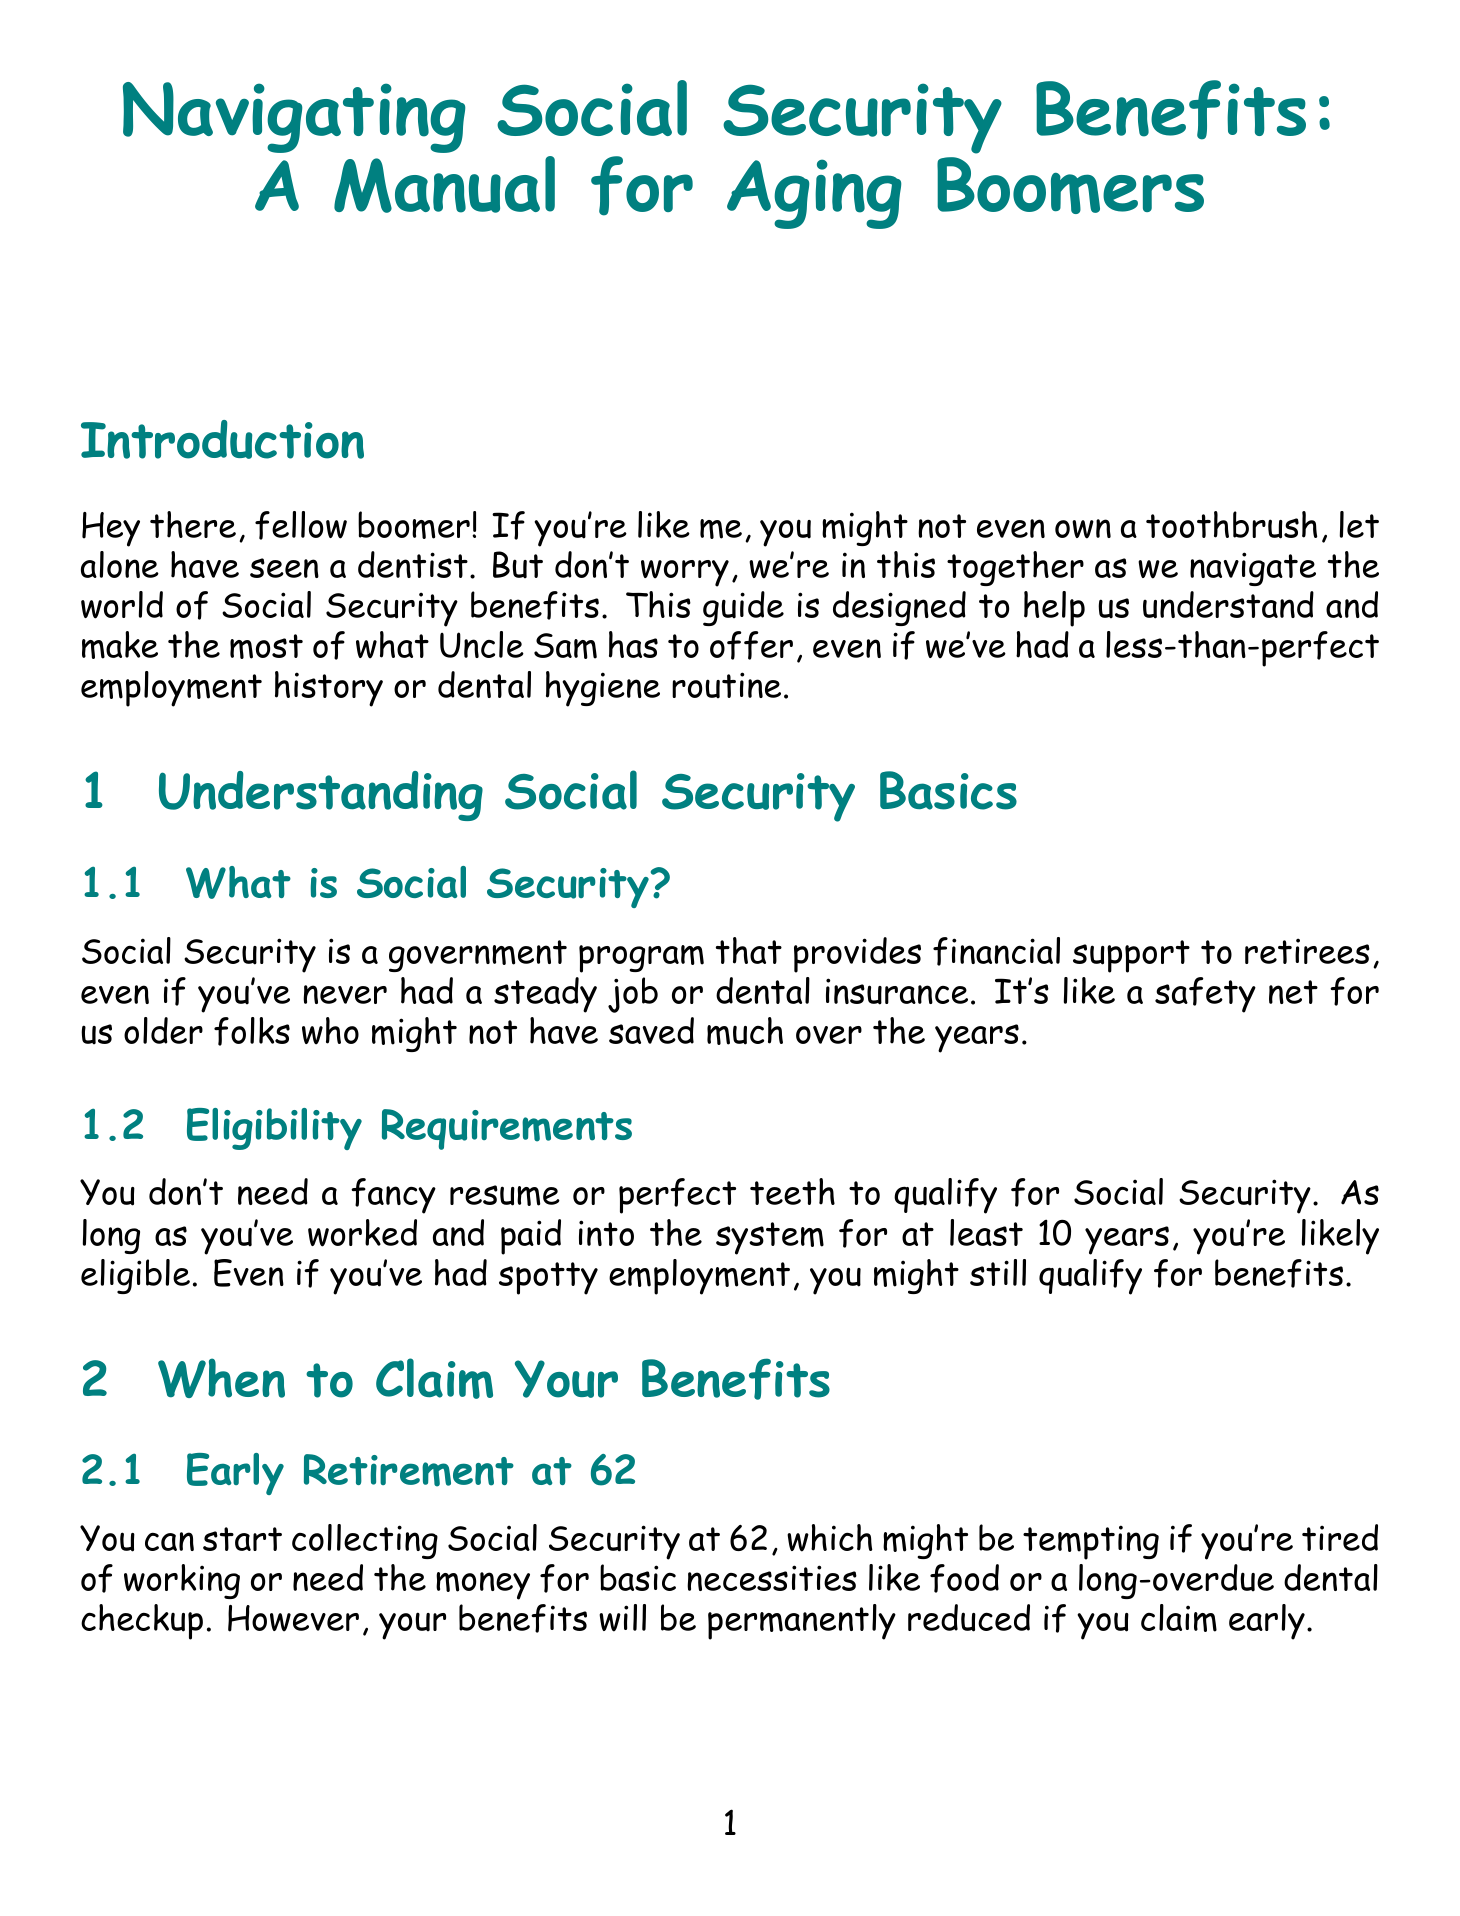What is Social Security? Social Security is a government program that provides financial support to retirees, even if you've never had a steady job or dental insurance.
Answer: A government program providing financial support What is the minimum work requirement to qualify for Social Security? You need to have worked and paid into the system for at least 10 years to qualify for Social Security.
Answer: 10 years What age can you start collecting Social Security? The manual mentions that you can start collecting Social Security at 62, but your benefits will be permanently reduced if you claim early.
Answer: 62 What is Full Retirement Age for most boomers? Full Retirement Age is between 66 and 67 for most boomers, which allows you to receive 100% of your benefit.
Answer: 66 to 67 What advantage do you get if you claim Social Security at 70? Claiming at 70 allows you to get the maximum benefit, which could help with health expenses.
Answer: Maximum benefit What considerations should you make when budgeting on Social Security? You should prioritize essential expenses like food and housing while considering low-cost dental clinics in your area.
Answer: Prioritize essential expenses What is one resource mentioned to help you create a my Social Security account? The local library is often mentioned as a resource offering free computer classes.
Answer: Local library At what age do you become eligible for Medicare? You become eligible for Medicare when you turn 65.
Answer: 65 What additional income assistance might you qualify for if your Social Security benefit is low? You might qualify for Supplemental Security Income (SSI) if your Social Security benefit is very low.
Answer: Supplemental Security Income (SSI) 